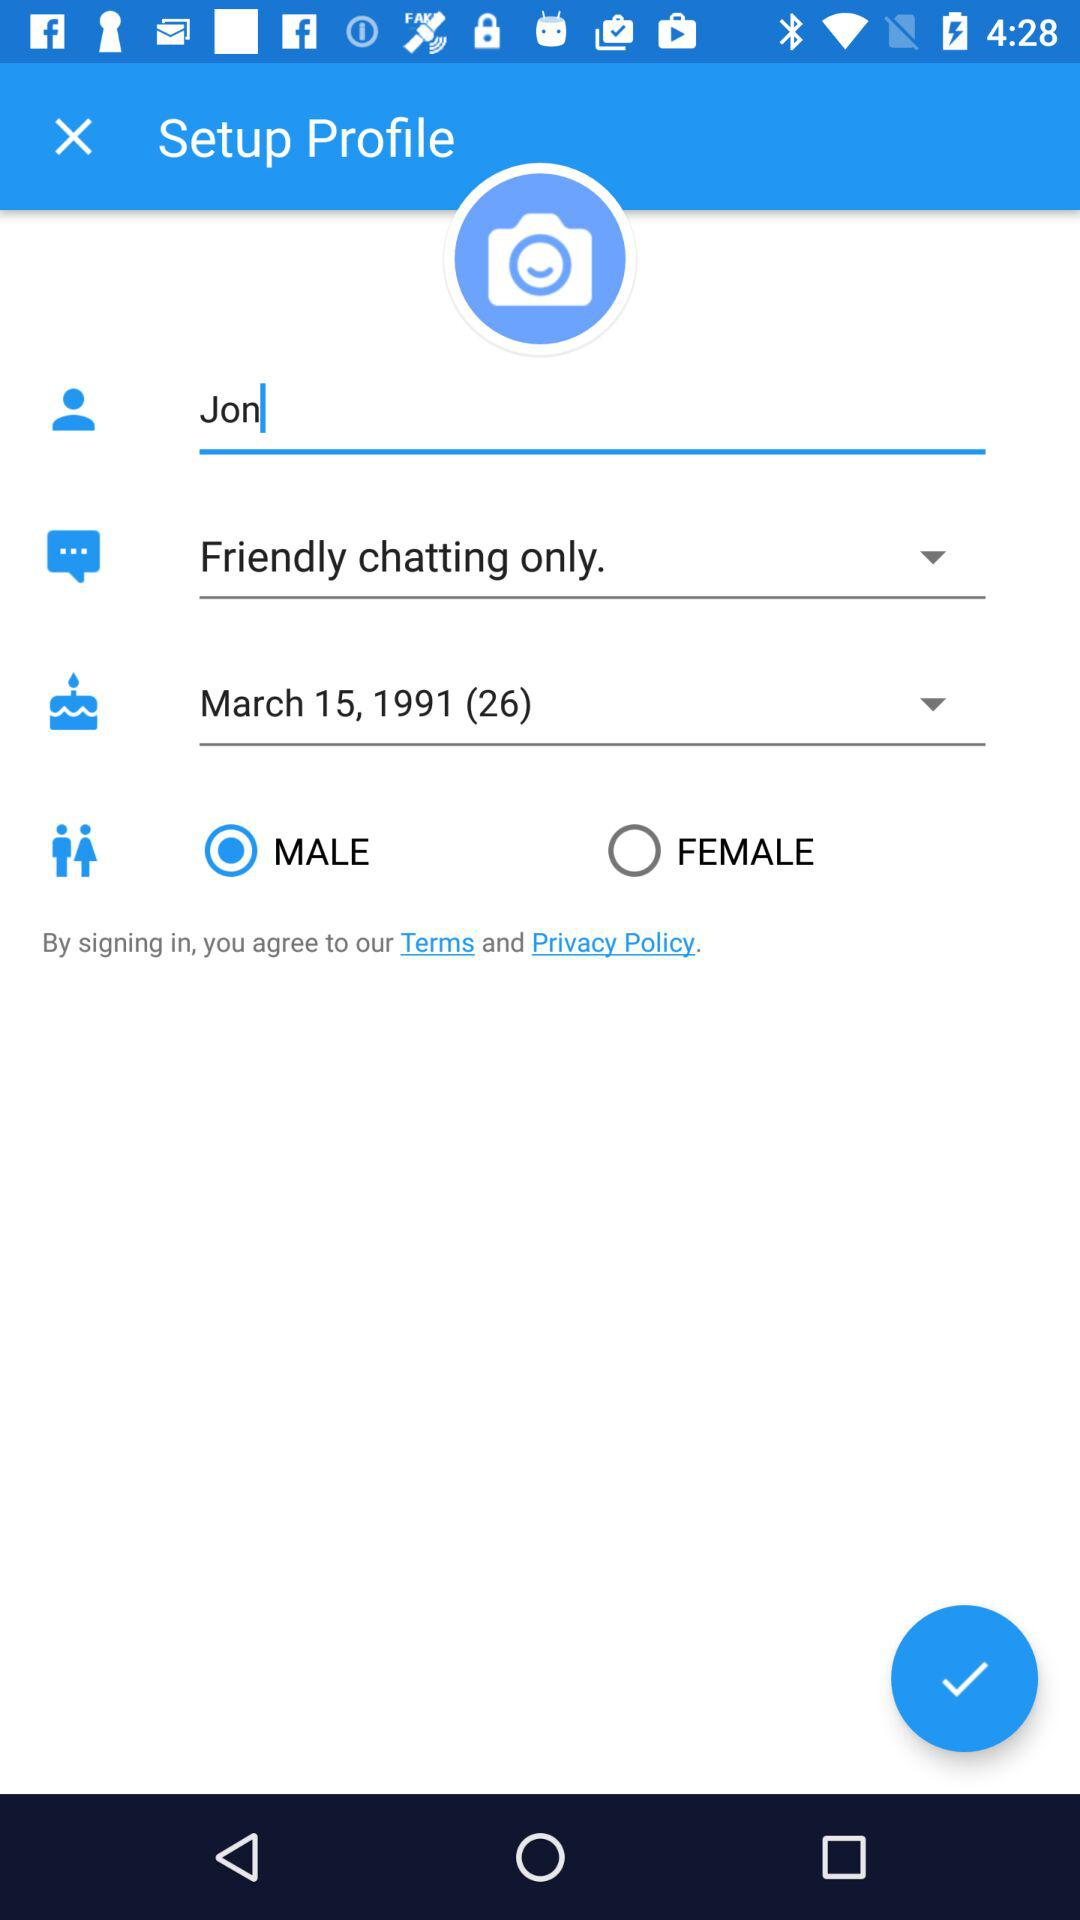How many years old is the user?
Answer the question using a single word or phrase. 26 